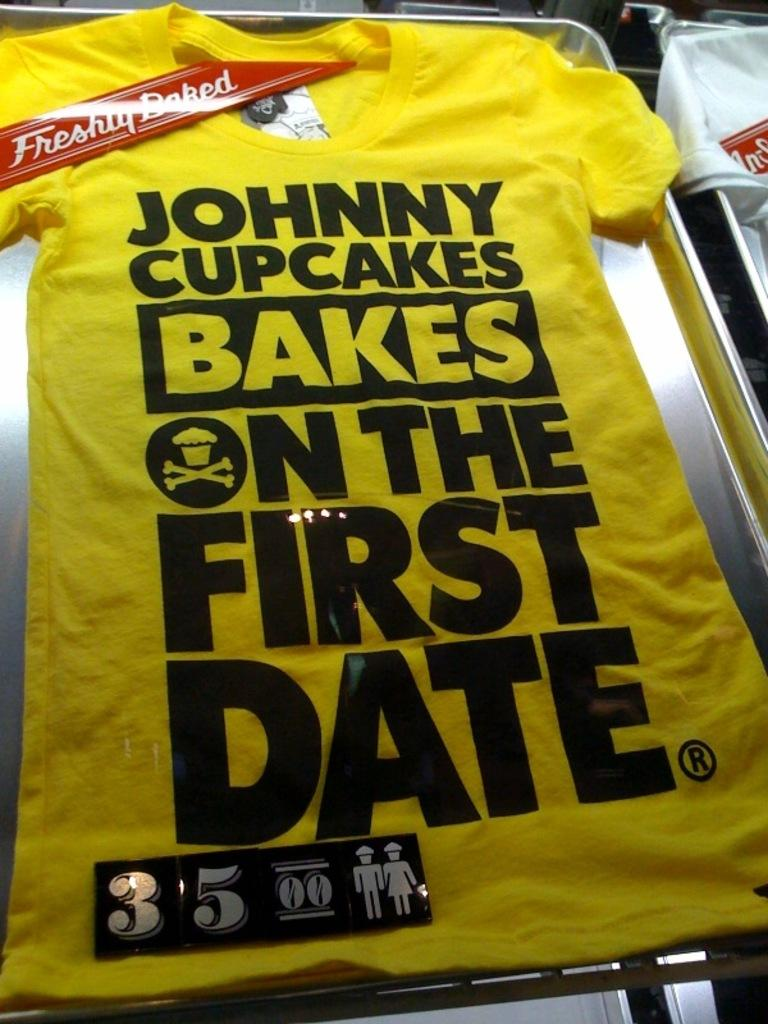<image>
Present a compact description of the photo's key features. Yellow shirt that says "Johnny Cupcakes" on the front. 